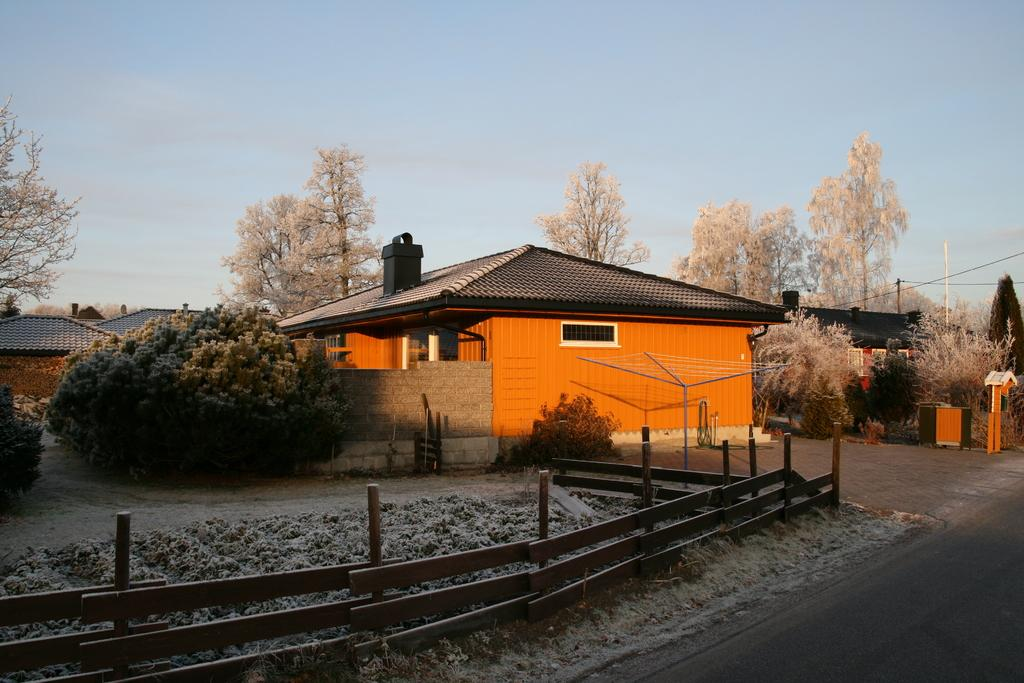What type of natural elements can be seen in the image? There are trees in the image. What type of man-made structures are present in the image? There are buildings in the image. What objects are supporting the wires in the image? There are poles in the image. What is visible in the background of the image? The sky is visible in the image. What type of sweater is hanging on the pole in the image? There is no sweater present in the image; it features trees, buildings, poles, wires, and the sky. How does the brake system work on the wires in the image? There is no brake system present in the image; it only shows wires supported by poles. 